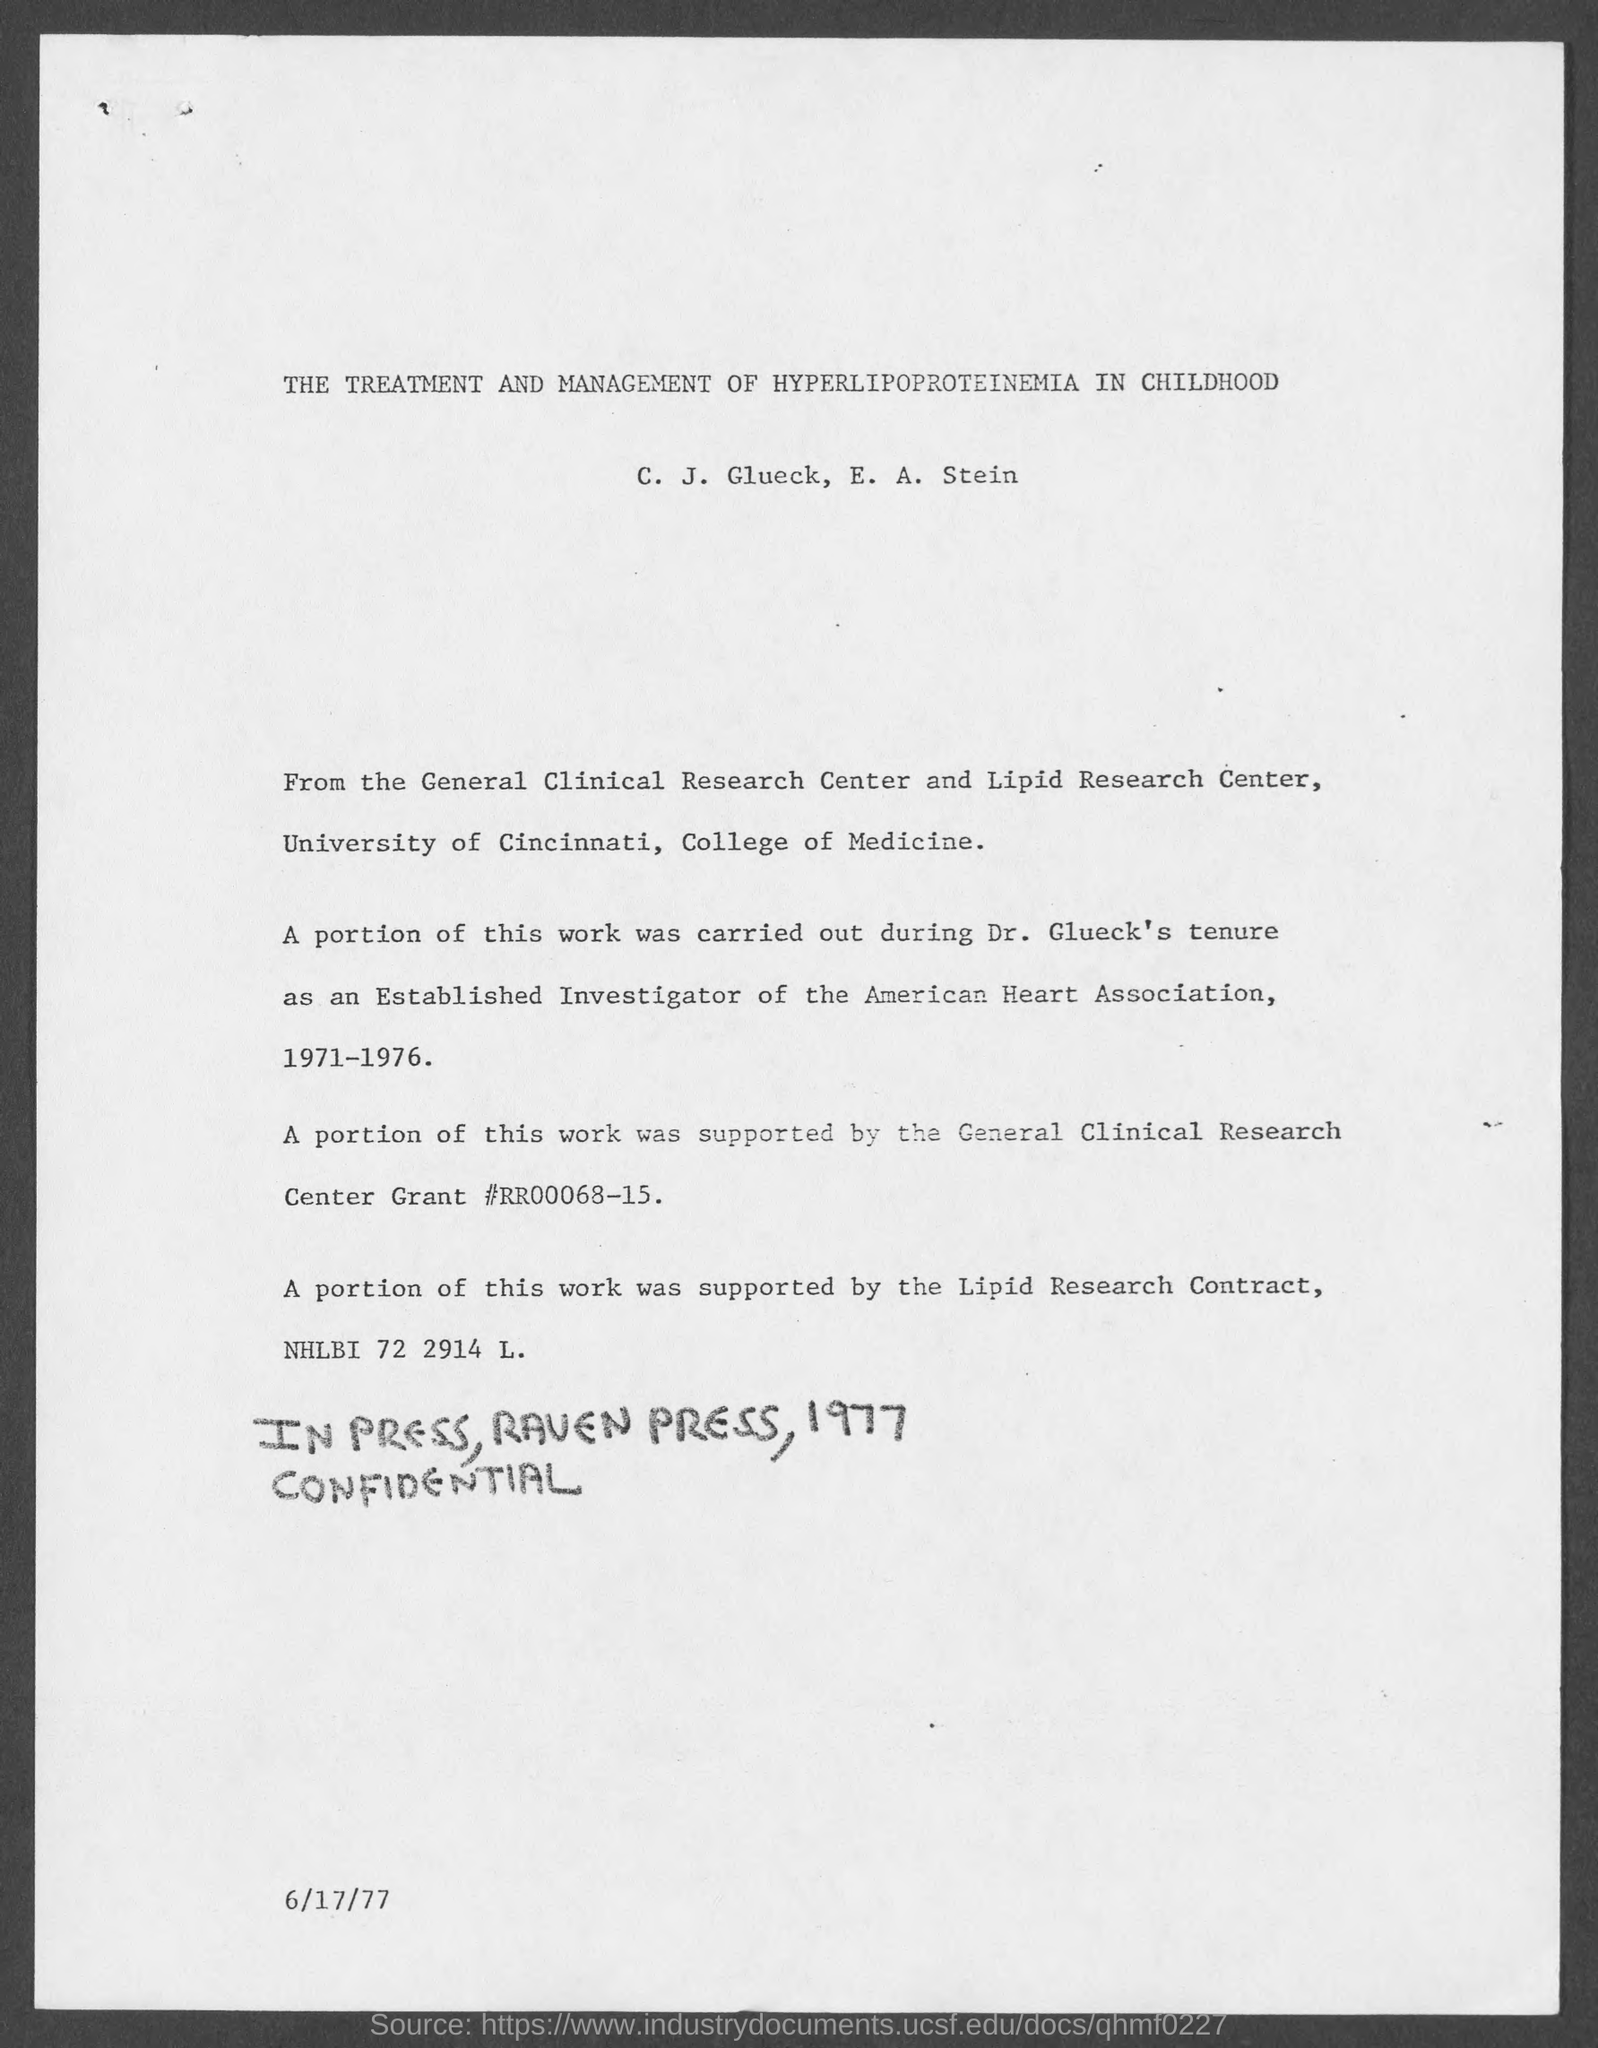List a handful of essential elements in this visual. The date at the bottom of the page is June 17th, 1977. 